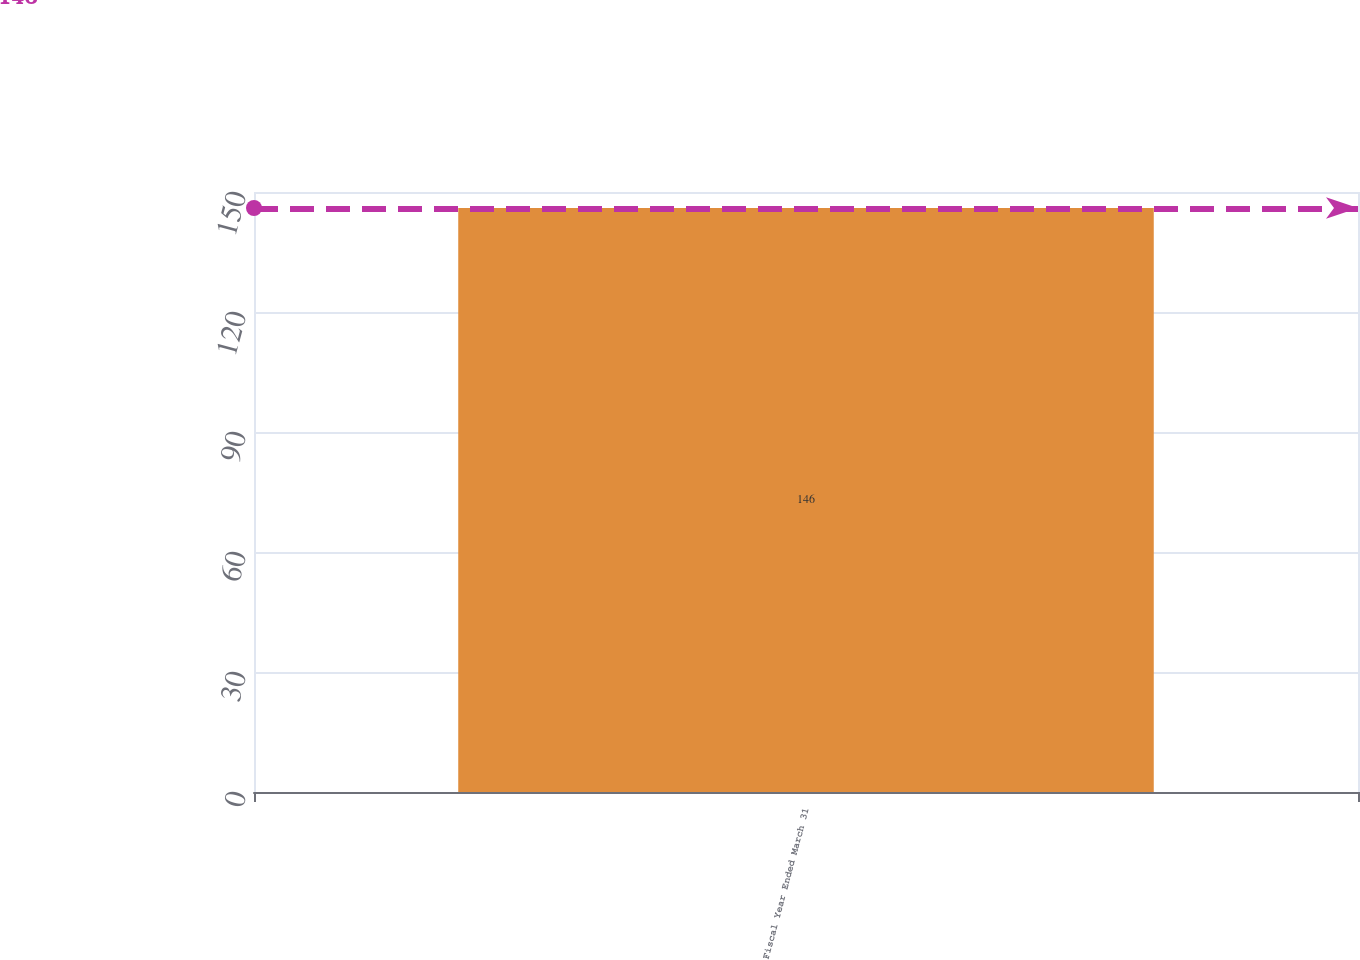Convert chart to OTSL. <chart><loc_0><loc_0><loc_500><loc_500><bar_chart><fcel>Fiscal Year Ended March 31<nl><fcel>146<nl></chart> 